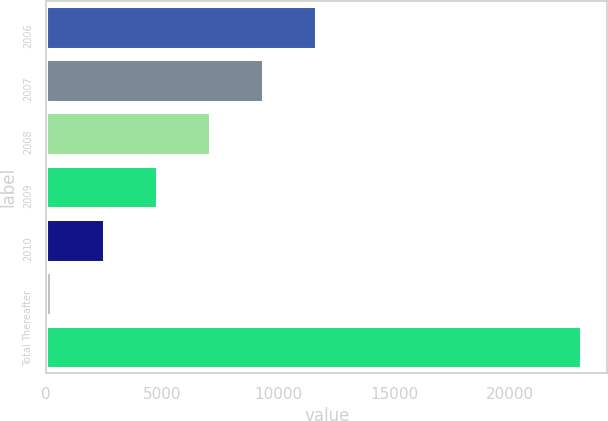Convert chart to OTSL. <chart><loc_0><loc_0><loc_500><loc_500><bar_chart><fcel>2006<fcel>2007<fcel>2008<fcel>2009<fcel>2010<fcel>Thereafter<fcel>Total<nl><fcel>11624.5<fcel>9339.2<fcel>7053.9<fcel>4768.6<fcel>2483.3<fcel>198<fcel>23051<nl></chart> 